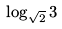<formula> <loc_0><loc_0><loc_500><loc_500>\log _ { \sqrt { 2 } } 3</formula> 